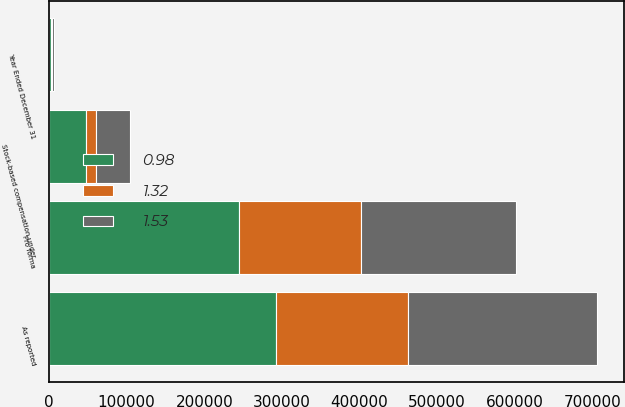<chart> <loc_0><loc_0><loc_500><loc_500><stacked_bar_chart><ecel><fcel>Year Ended December 31<fcel>As reported<fcel>Stock-based compensation under<fcel>Pro forma<nl><fcel>1.53<fcel>2003<fcel>243697<fcel>43310<fcel>200387<nl><fcel>0.98<fcel>2002<fcel>292435<fcel>47761<fcel>244674<nl><fcel>1.32<fcel>2001<fcel>169815<fcel>12784<fcel>157031<nl></chart> 